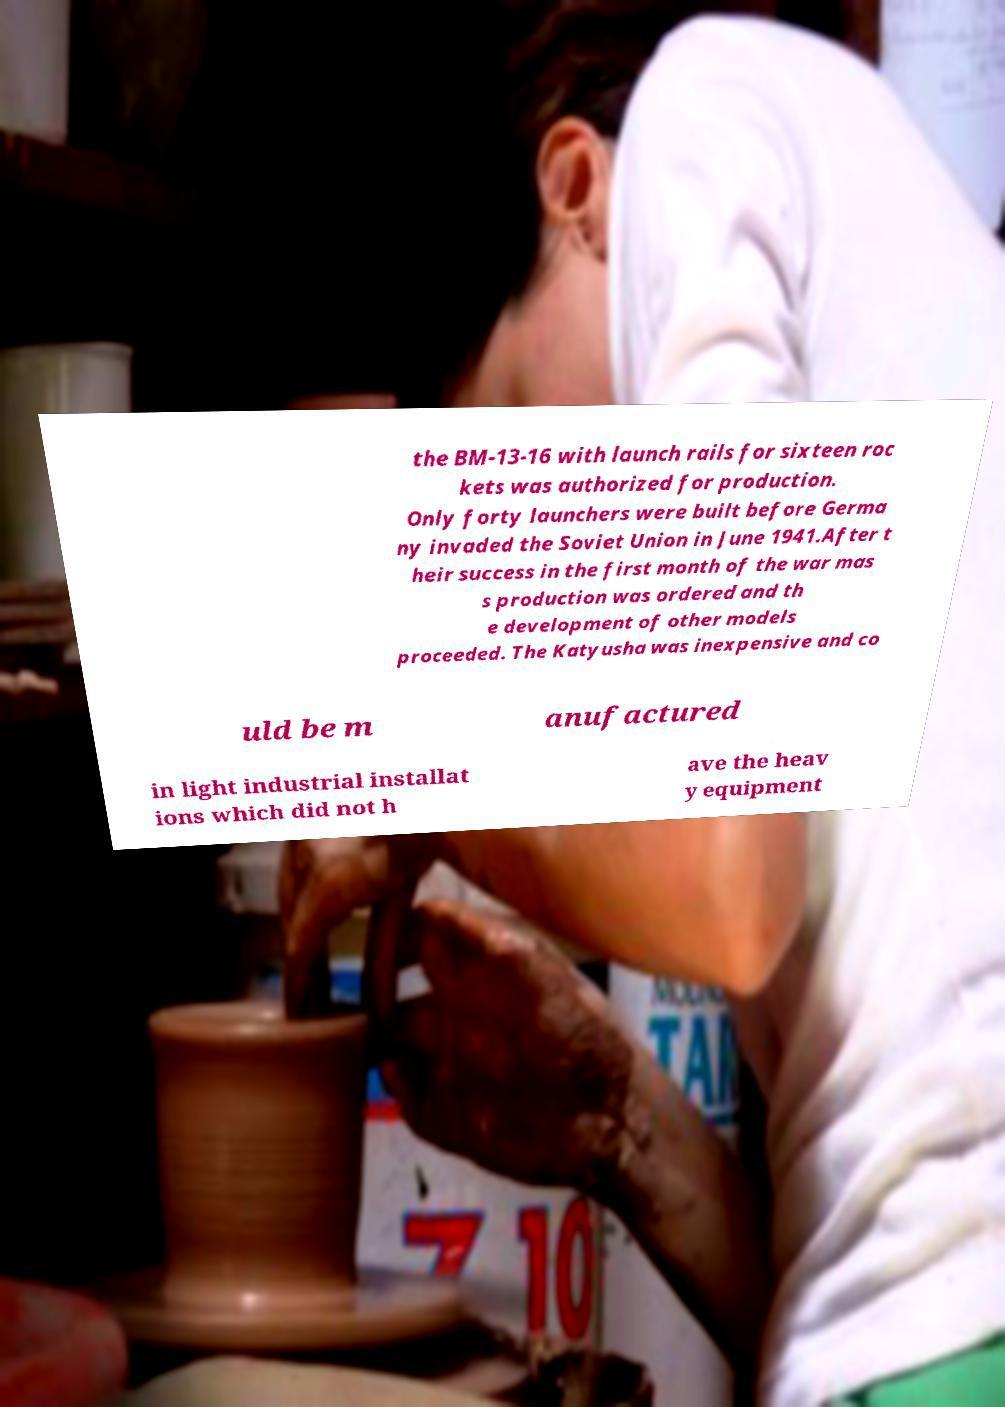I need the written content from this picture converted into text. Can you do that? the BM-13-16 with launch rails for sixteen roc kets was authorized for production. Only forty launchers were built before Germa ny invaded the Soviet Union in June 1941.After t heir success in the first month of the war mas s production was ordered and th e development of other models proceeded. The Katyusha was inexpensive and co uld be m anufactured in light industrial installat ions which did not h ave the heav y equipment 